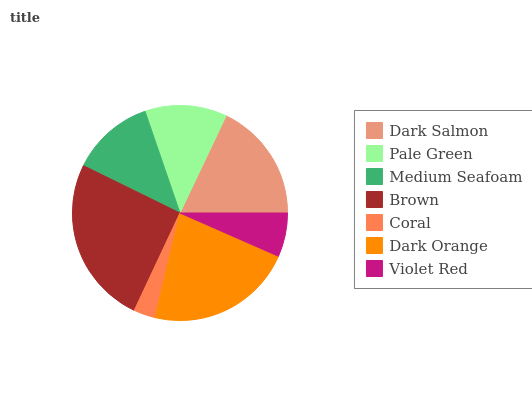Is Coral the minimum?
Answer yes or no. Yes. Is Brown the maximum?
Answer yes or no. Yes. Is Pale Green the minimum?
Answer yes or no. No. Is Pale Green the maximum?
Answer yes or no. No. Is Dark Salmon greater than Pale Green?
Answer yes or no. Yes. Is Pale Green less than Dark Salmon?
Answer yes or no. Yes. Is Pale Green greater than Dark Salmon?
Answer yes or no. No. Is Dark Salmon less than Pale Green?
Answer yes or no. No. Is Medium Seafoam the high median?
Answer yes or no. Yes. Is Medium Seafoam the low median?
Answer yes or no. Yes. Is Brown the high median?
Answer yes or no. No. Is Pale Green the low median?
Answer yes or no. No. 